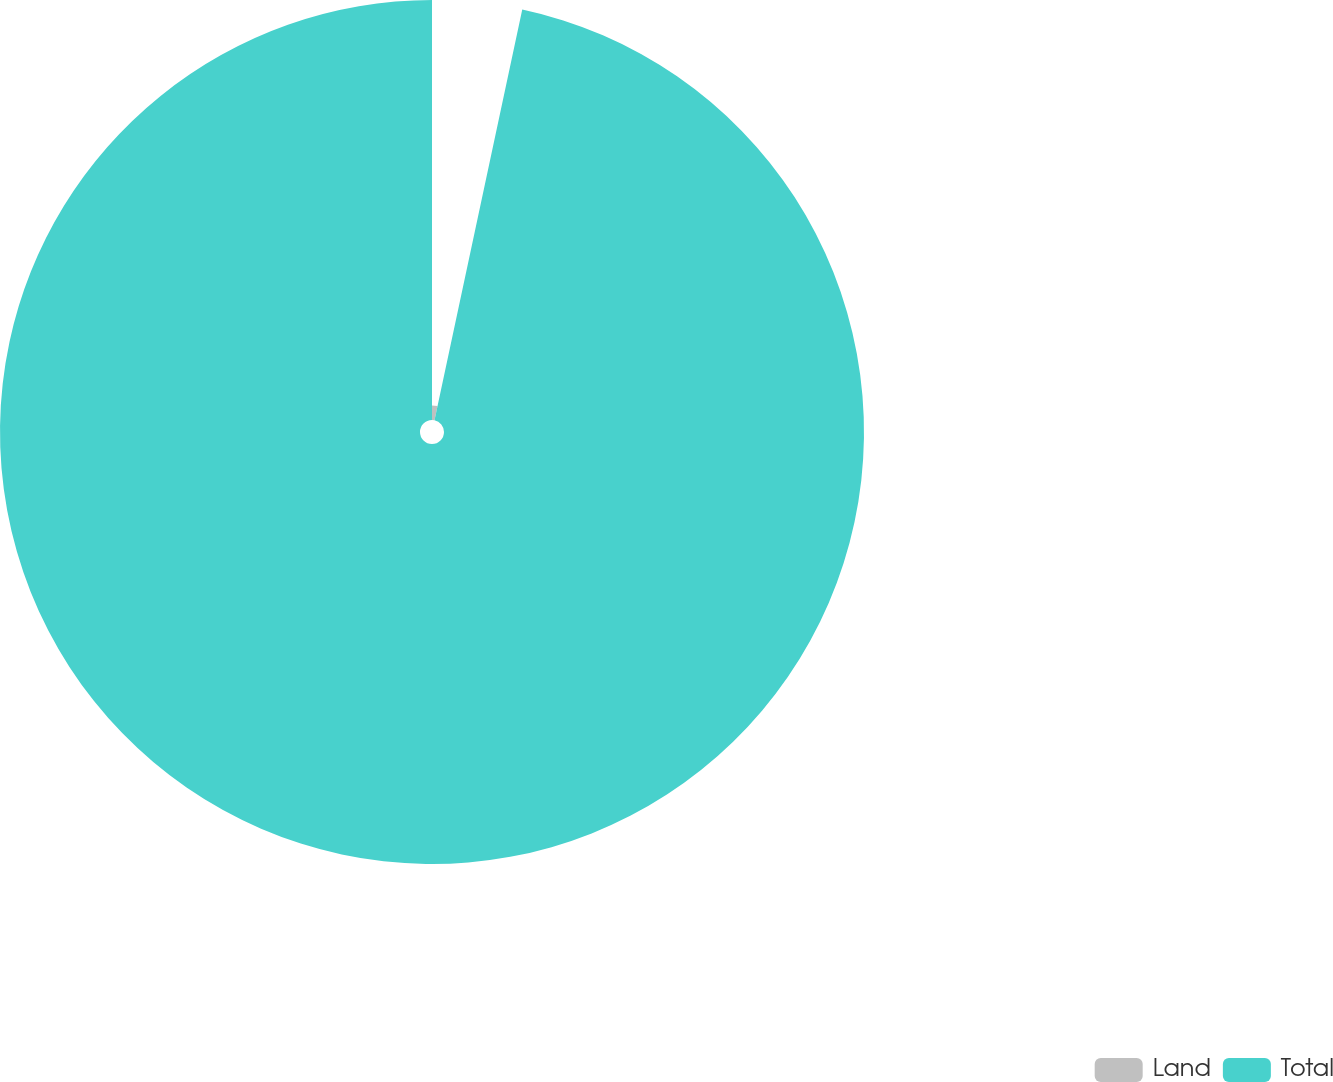Convert chart to OTSL. <chart><loc_0><loc_0><loc_500><loc_500><pie_chart><fcel>Land<fcel>Total<nl><fcel>3.35%<fcel>96.65%<nl></chart> 